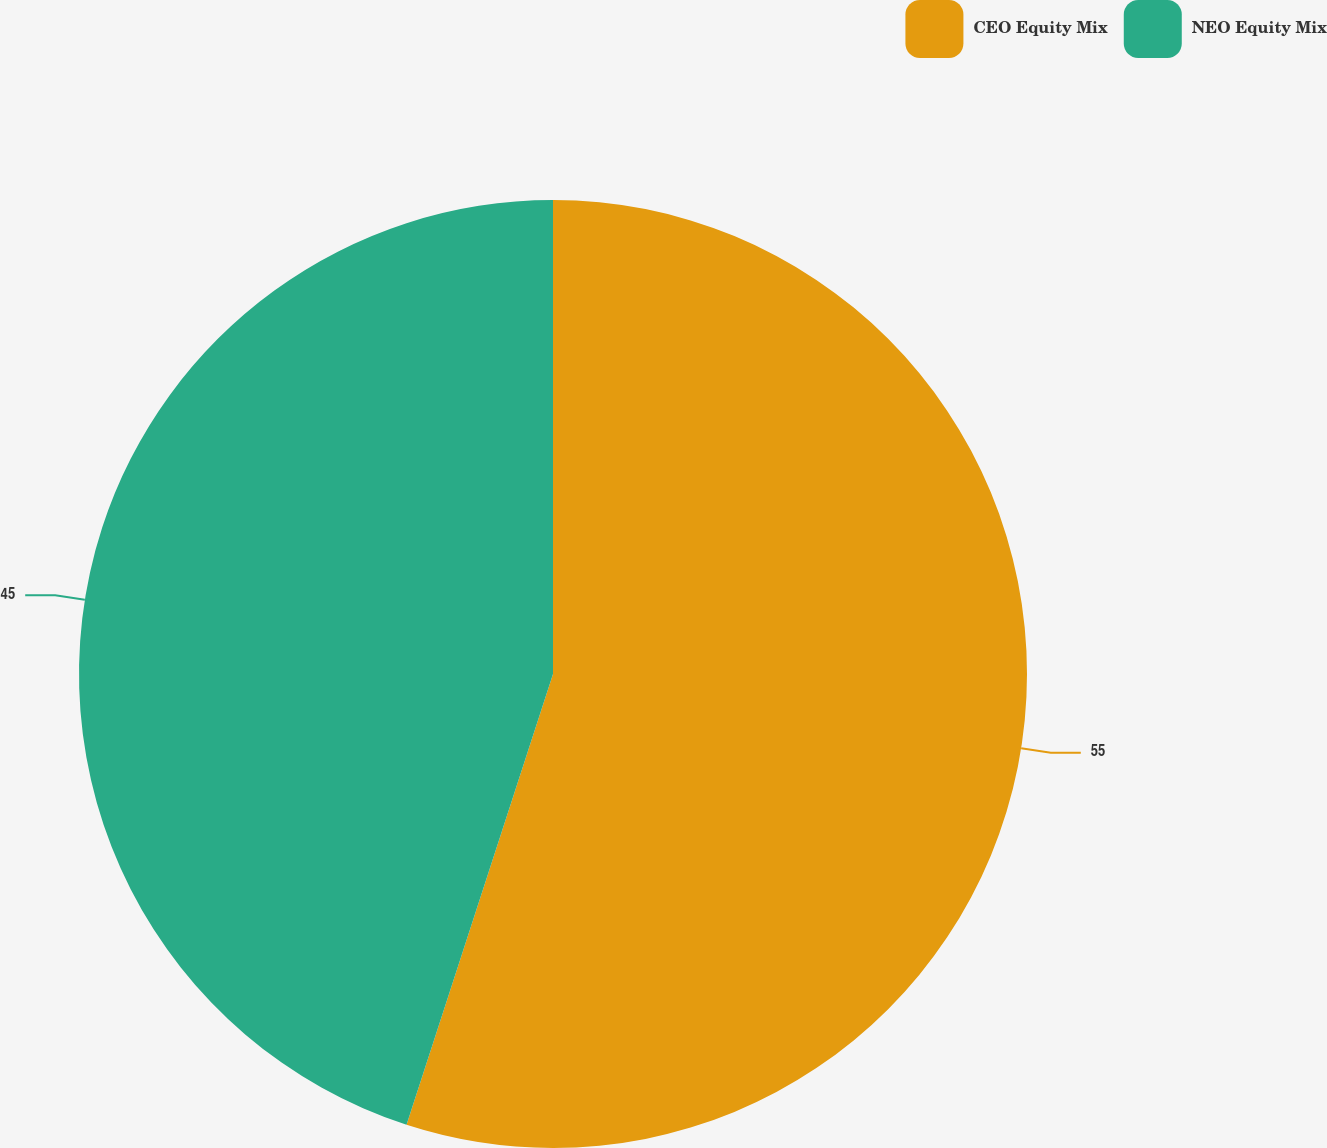Convert chart to OTSL. <chart><loc_0><loc_0><loc_500><loc_500><pie_chart><fcel>CEO Equity Mix<fcel>NEO Equity Mix<nl><fcel>55.0%<fcel>45.0%<nl></chart> 